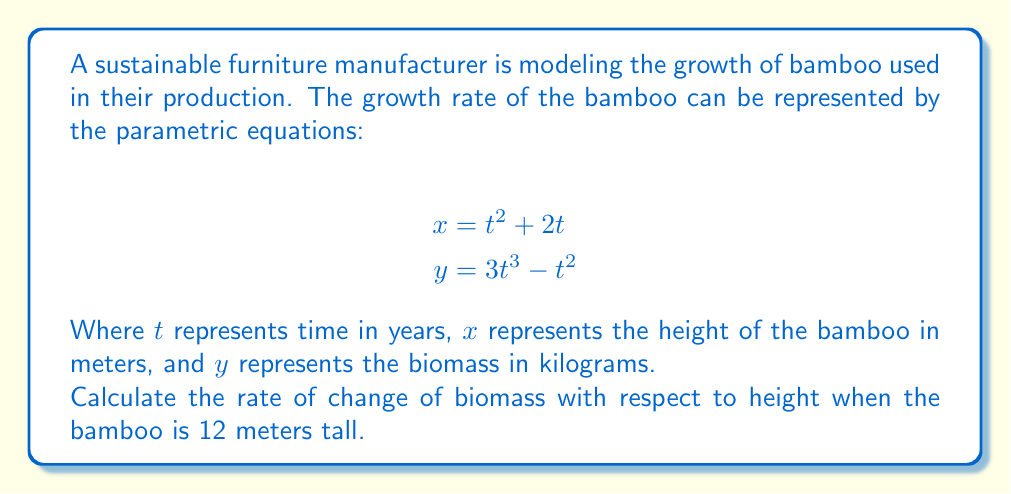What is the answer to this math problem? To solve this problem, we need to follow these steps:

1) First, we need to find the value of $t$ when the height ($x$) is 12 meters.
   $$12 = t^2 + 2t$$

2) This is a quadratic equation. We can solve it using the quadratic formula:
   $$t = \frac{-b \pm \sqrt{b^2 - 4ac}}{2a}$$
   Where $a=1$, $b=2$, and $c=-12$

3) Solving this:
   $$t = \frac{-2 \pm \sqrt{4 + 48}}{2} = \frac{-2 \pm \sqrt{52}}{2} = \frac{-2 \pm 7.21}{2}$$

4) We take the positive root as time can't be negative:
   $$t \approx 2.61$$

5) Now we need to find $\frac{dy}{dx}$. In parametric equations, this is given by:
   $$\frac{dy}{dx} = \frac{\frac{dy}{dt}}{\frac{dx}{dt}}$$

6) Let's find $\frac{dx}{dt}$ and $\frac{dy}{dt}$:
   $$\frac{dx}{dt} = 2t + 2$$
   $$\frac{dy}{dt} = 9t^2 - 2t$$

7) Now we can substitute these into our equation for $\frac{dy}{dx}$:
   $$\frac{dy}{dx} = \frac{9t^2 - 2t}{2t + 2}$$

8) Finally, we substitute our value of $t$:
   $$\frac{dy}{dx} = \frac{9(2.61)^2 - 2(2.61)}{2(2.61) + 2} \approx 3.11$$

Therefore, when the bamboo is 12 meters tall, the rate of change of biomass with respect to height is approximately 3.11 kg/m.
Answer: $\frac{dy}{dx} \approx 3.11$ kg/m 